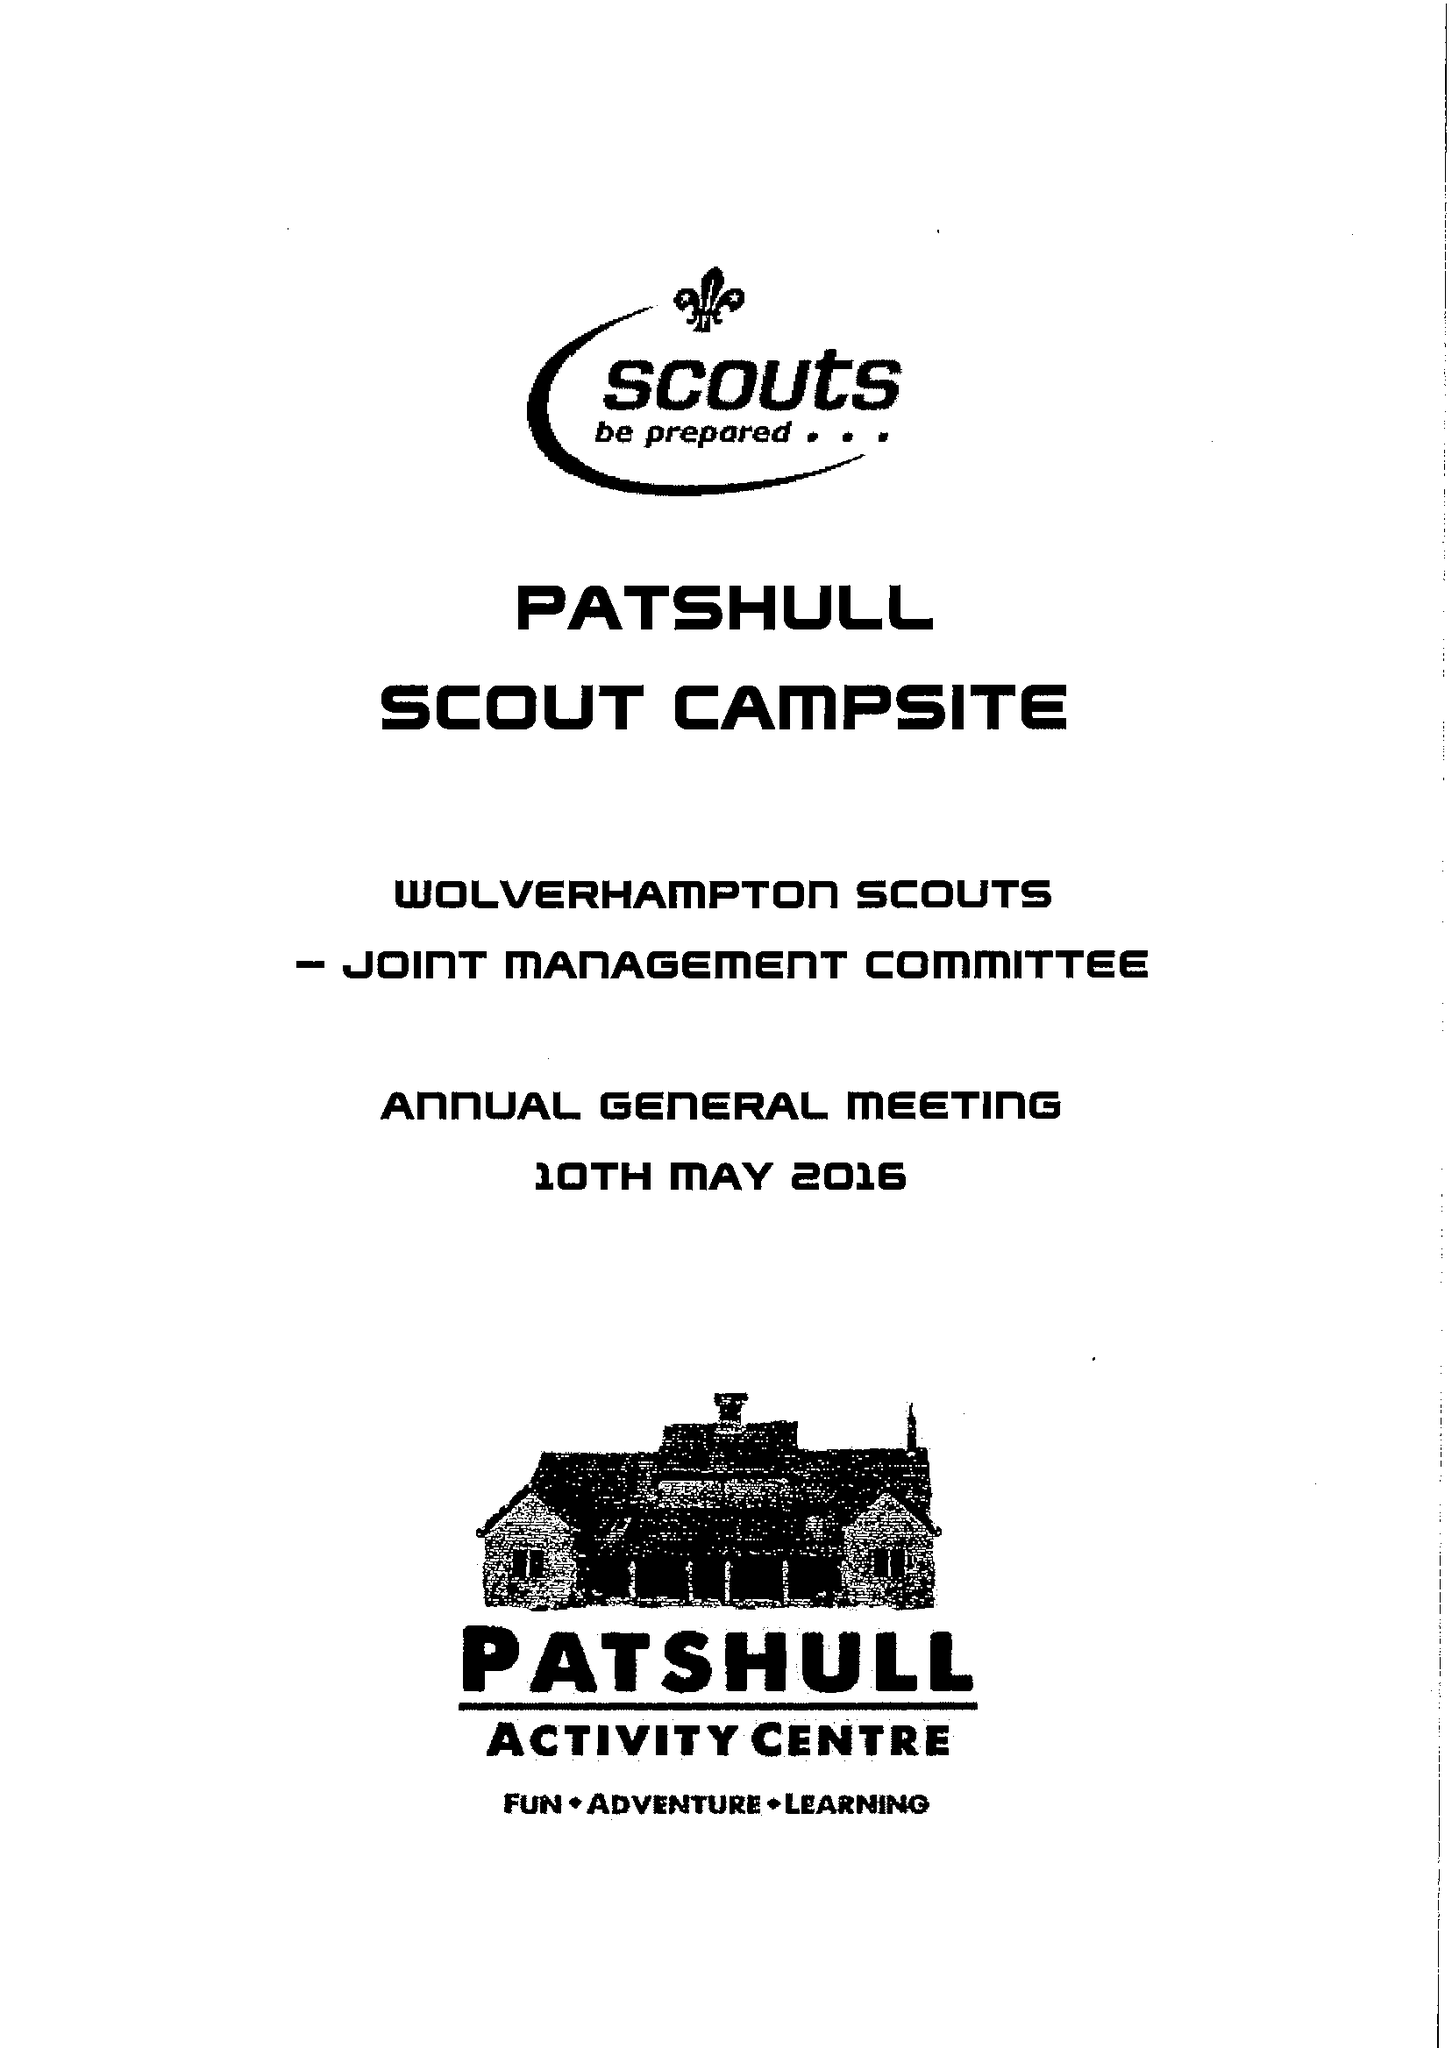What is the value for the charity_name?
Answer the question using a single word or phrase. Wolverhampton Scouts 